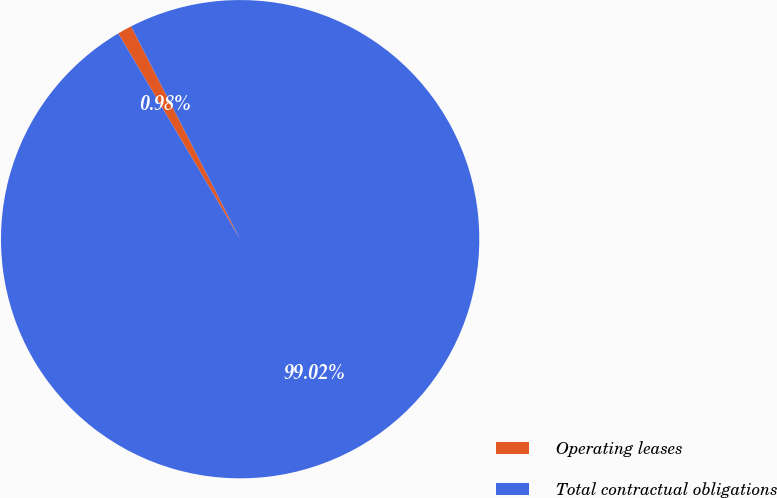<chart> <loc_0><loc_0><loc_500><loc_500><pie_chart><fcel>Operating leases<fcel>Total contractual obligations<nl><fcel>0.98%<fcel>99.02%<nl></chart> 